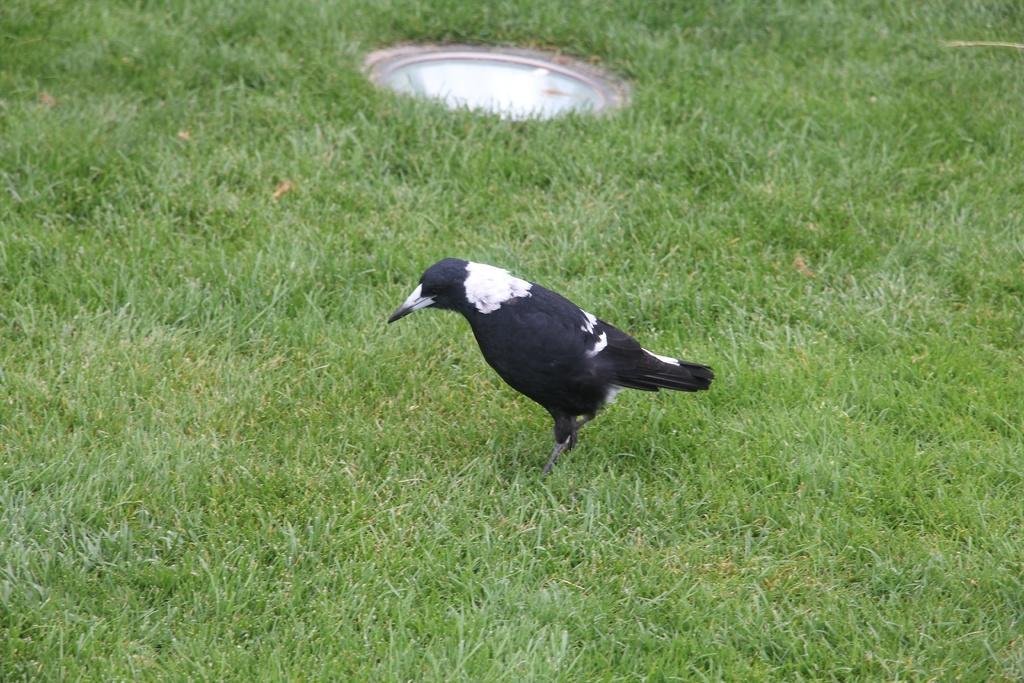Describe this image in one or two sentences. In this picture we can see a bird on the ground. And this is the grass. 